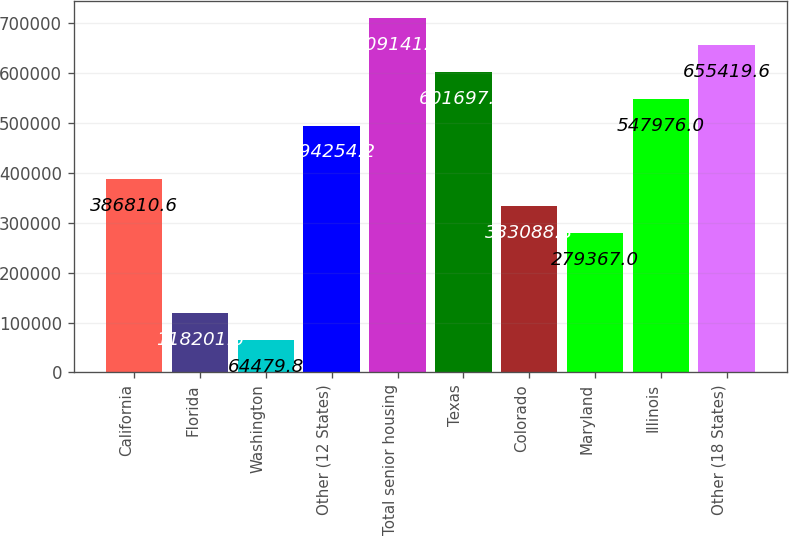Convert chart. <chart><loc_0><loc_0><loc_500><loc_500><bar_chart><fcel>California<fcel>Florida<fcel>Washington<fcel>Other (12 States)<fcel>Total senior housing<fcel>Texas<fcel>Colorado<fcel>Maryland<fcel>Illinois<fcel>Other (18 States)<nl><fcel>386811<fcel>118202<fcel>64479.8<fcel>494254<fcel>709141<fcel>601698<fcel>333089<fcel>279367<fcel>547976<fcel>655420<nl></chart> 